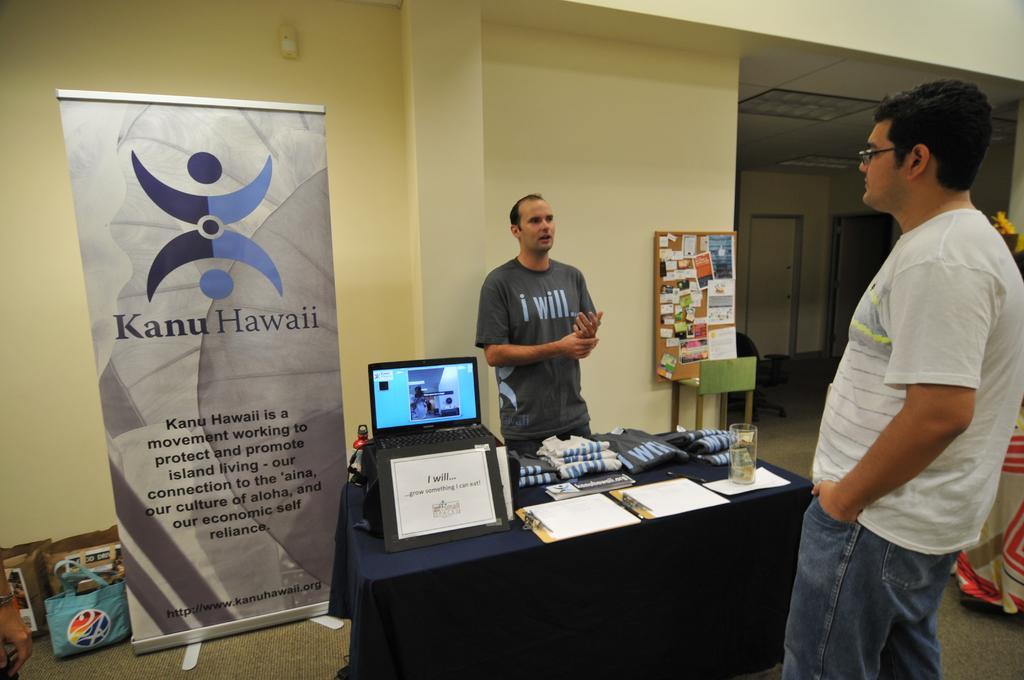Can you describe this image briefly? As we can see in the image, there are two people standing. In front of them there is table. On table there is a laptop, a board, clothes and on the left side there are some boxes and a banner and the wall is in yellow color. 